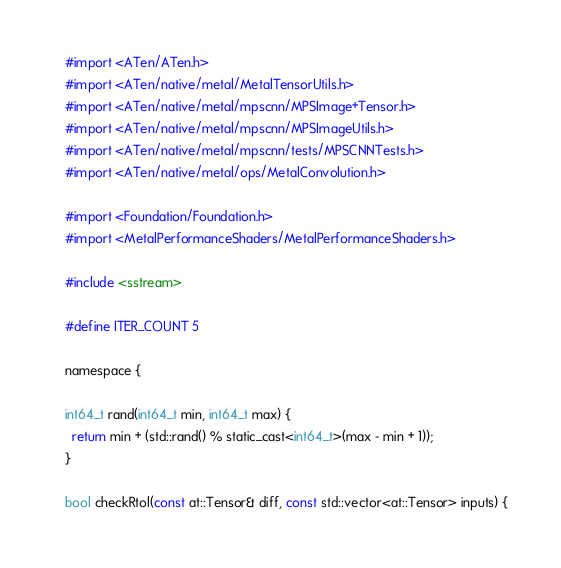Convert code to text. <code><loc_0><loc_0><loc_500><loc_500><_ObjectiveC_>#import <ATen/ATen.h>
#import <ATen/native/metal/MetalTensorUtils.h>
#import <ATen/native/metal/mpscnn/MPSImage+Tensor.h>
#import <ATen/native/metal/mpscnn/MPSImageUtils.h>
#import <ATen/native/metal/mpscnn/tests/MPSCNNTests.h>
#import <ATen/native/metal/ops/MetalConvolution.h>

#import <Foundation/Foundation.h>
#import <MetalPerformanceShaders/MetalPerformanceShaders.h>

#include <sstream>

#define ITER_COUNT 5

namespace {

int64_t rand(int64_t min, int64_t max) {
  return min + (std::rand() % static_cast<int64_t>(max - min + 1));
}

bool checkRtol(const at::Tensor& diff, const std::vector<at::Tensor> inputs) {</code> 